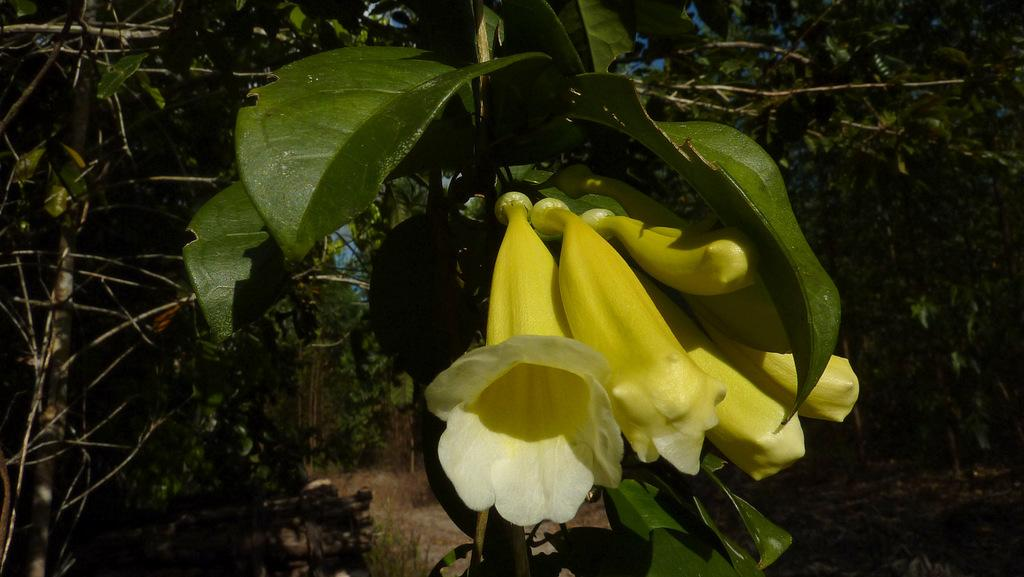What type of vegetation is present in the image? There are trees and flowers in the image. What can be observed about the leaves of the flowers? The flowers have green leaves. What colors are the flowers in the image? The flowers are white and yellow in color. What type of mask is being worn by the flowers in the image? There are no masks present in the image; it features trees and flowers with green leaves and white and yellow colors. What type of badge can be seen on the trees in the image? There are no badges present in the image; it features trees and flowers with green leaves and white and yellow colors. 